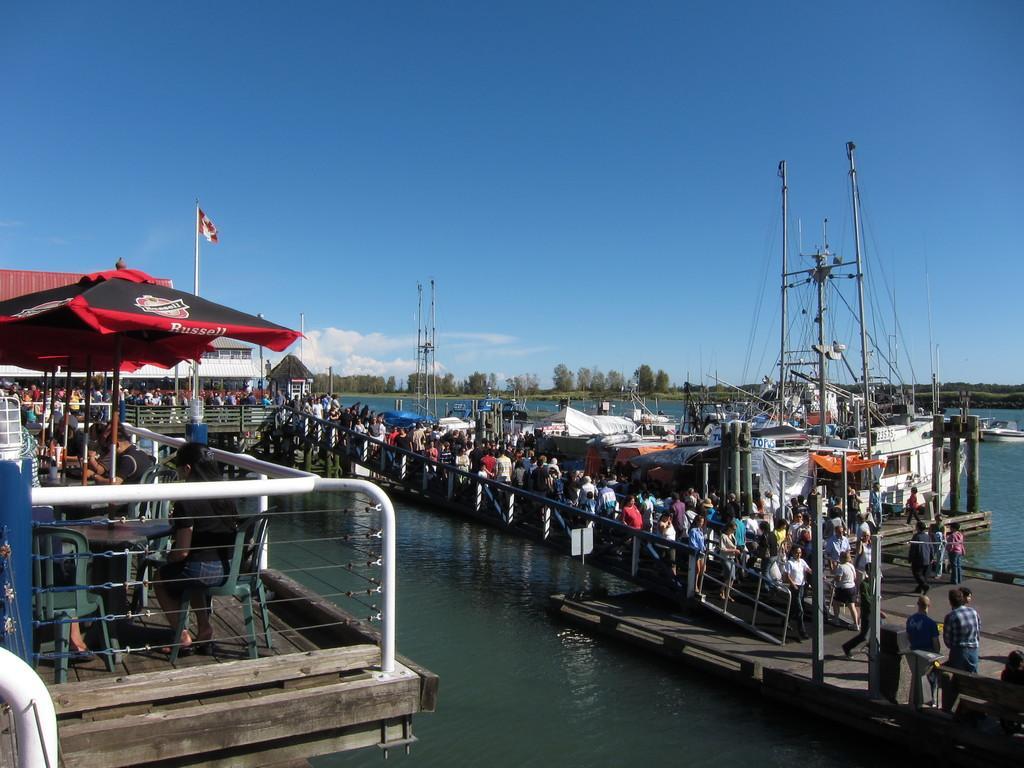Could you give a brief overview of what you see in this image? In this image we can see persons, bridgewater, ships, chairs, tents, buildings, trees, sky and clouds. 